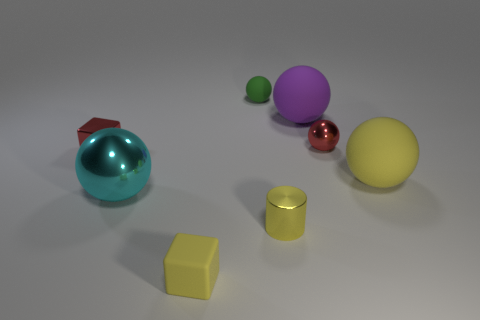Subtract all big purple balls. How many balls are left? 4 Subtract all purple spheres. How many spheres are left? 4 Subtract all green balls. Subtract all blue blocks. How many balls are left? 4 Add 1 small yellow cylinders. How many objects exist? 9 Subtract all blocks. How many objects are left? 6 Add 1 large green rubber cylinders. How many large green rubber cylinders exist? 1 Subtract 0 blue cylinders. How many objects are left? 8 Subtract all cyan objects. Subtract all small cubes. How many objects are left? 5 Add 7 purple matte objects. How many purple matte objects are left? 8 